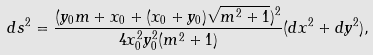<formula> <loc_0><loc_0><loc_500><loc_500>d s ^ { 2 } = \frac { ( y _ { 0 } m + x _ { 0 } + ( x _ { 0 } + y _ { 0 } ) \sqrt { m ^ { 2 } + 1 } ) ^ { 2 } } { 4 x _ { 0 } ^ { 2 } y _ { 0 } ^ { 2 } ( m ^ { 2 } + 1 ) } ( d x ^ { 2 } + d y ^ { 2 } ) ,</formula> 